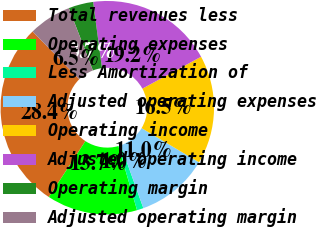<chart> <loc_0><loc_0><loc_500><loc_500><pie_chart><fcel>Total revenues less<fcel>Operating expenses<fcel>Less Amortization of<fcel>Adjusted operating expenses<fcel>Operating income<fcel>Adjusted operating income<fcel>Operating margin<fcel>Adjusted operating margin<nl><fcel>28.44%<fcel>13.71%<fcel>0.99%<fcel>10.97%<fcel>16.46%<fcel>19.2%<fcel>3.74%<fcel>6.48%<nl></chart> 